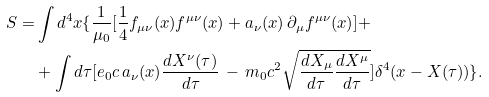Convert formula to latex. <formula><loc_0><loc_0><loc_500><loc_500>S = & \int d ^ { 4 } x \{ \frac { 1 } { \mu _ { 0 } } [ \frac { 1 } { 4 } f _ { \mu \nu } ( x ) f ^ { \mu \nu } ( x ) + a _ { \nu } ( x ) \, \partial _ { \mu } f ^ { \mu \nu } ( x ) ] + \\ & + \int d \tau [ e _ { 0 } c \, a _ { \nu } ( x ) \frac { d X ^ { \nu } ( \tau ) } { d \tau } \, - \, m _ { 0 } c ^ { 2 } \sqrt { \frac { d X _ { \mu } } { d \tau } \frac { d X ^ { \mu } } { d \tau } } ] \delta ^ { 4 } ( x - X ( \tau ) ) \} .</formula> 